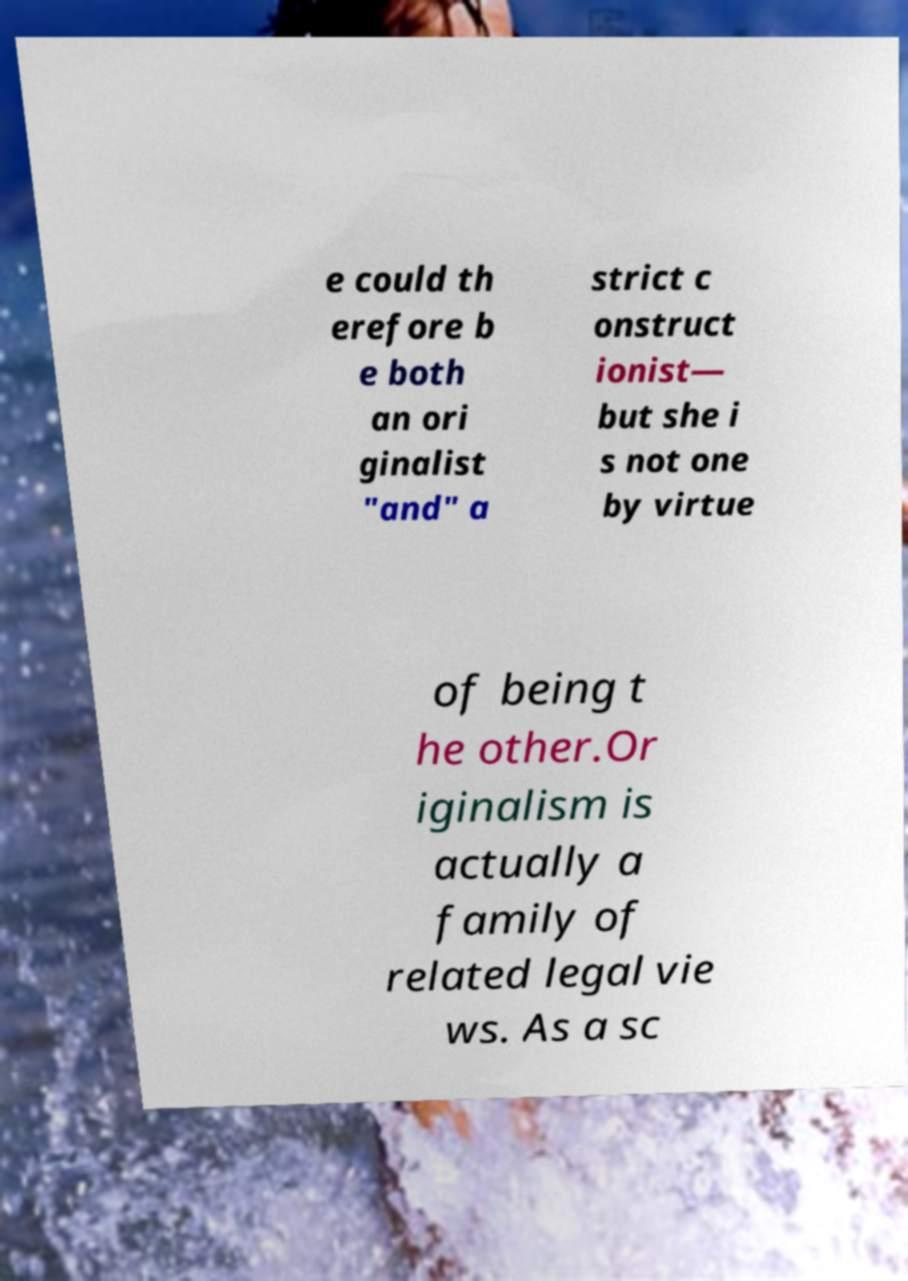Can you accurately transcribe the text from the provided image for me? e could th erefore b e both an ori ginalist "and" a strict c onstruct ionist— but she i s not one by virtue of being t he other.Or iginalism is actually a family of related legal vie ws. As a sc 